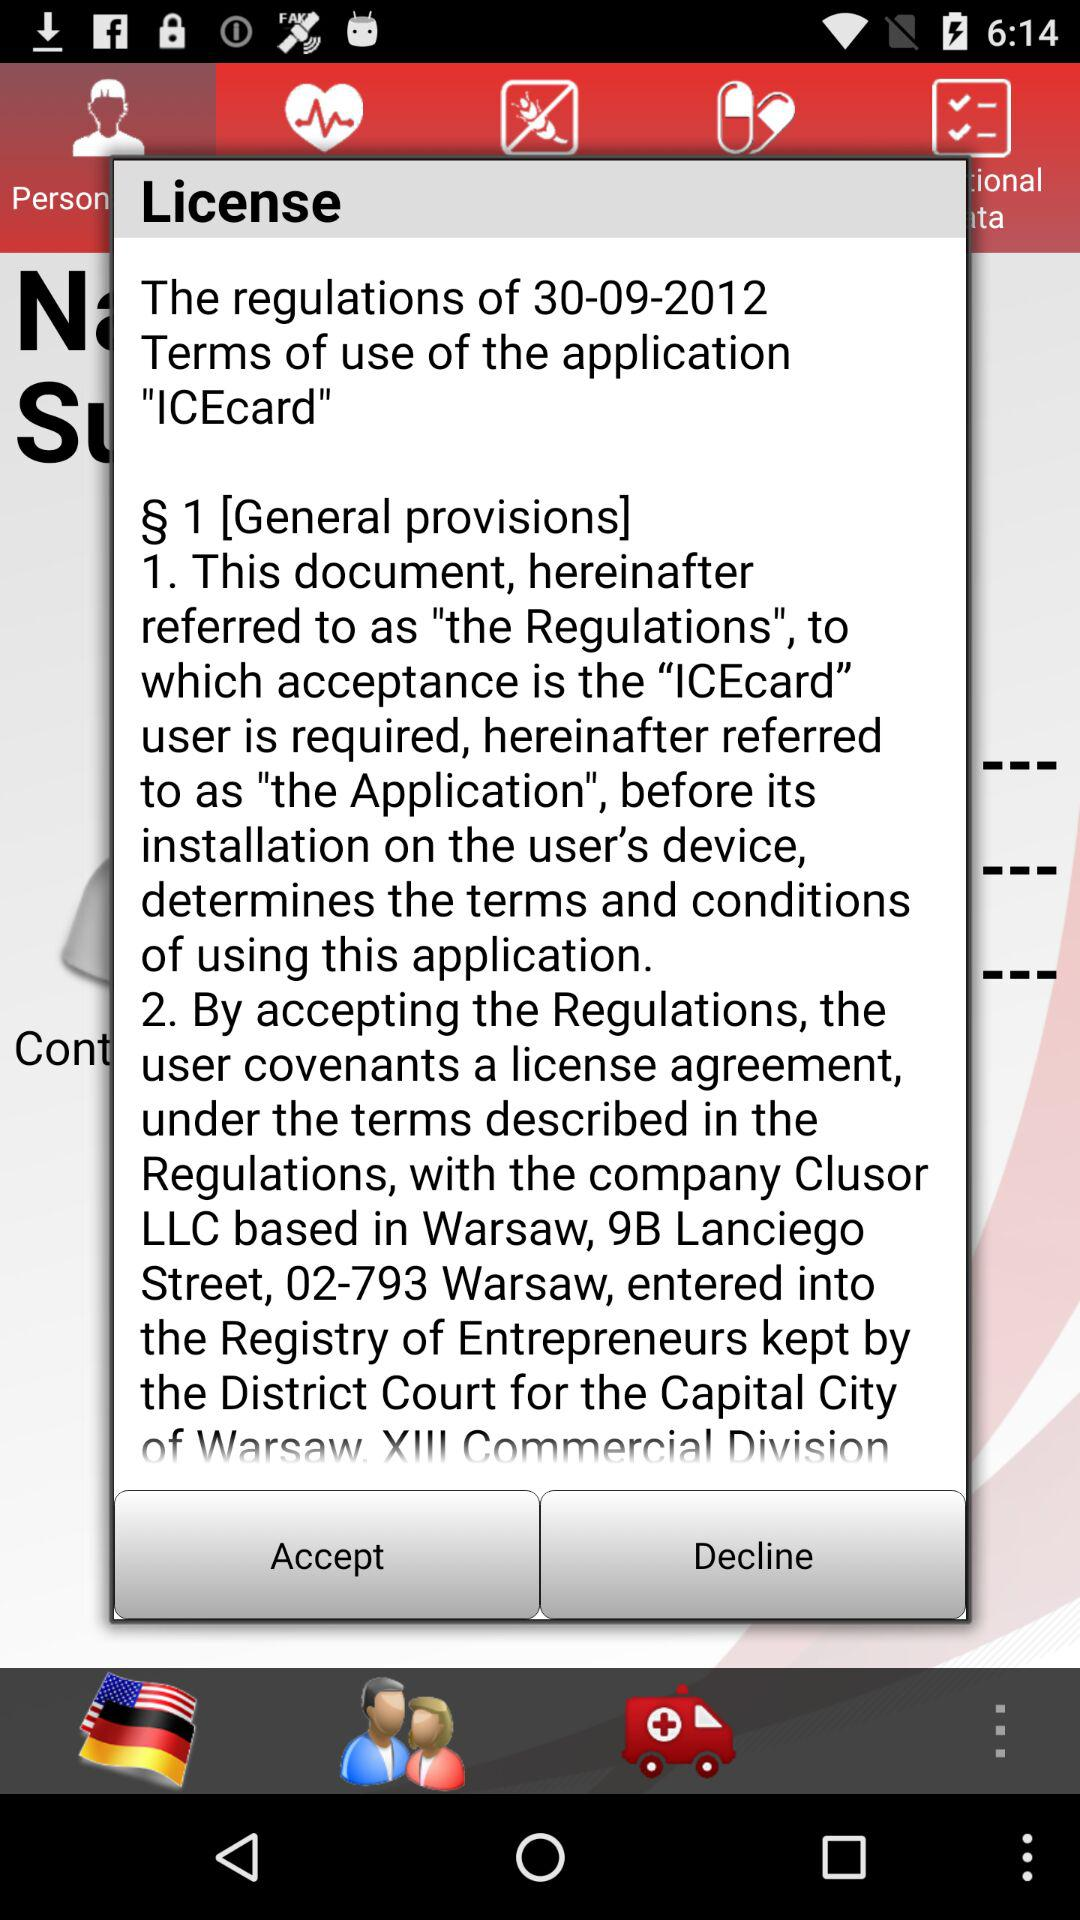What is the regulation date? The regulation date is September 30, 2012. 